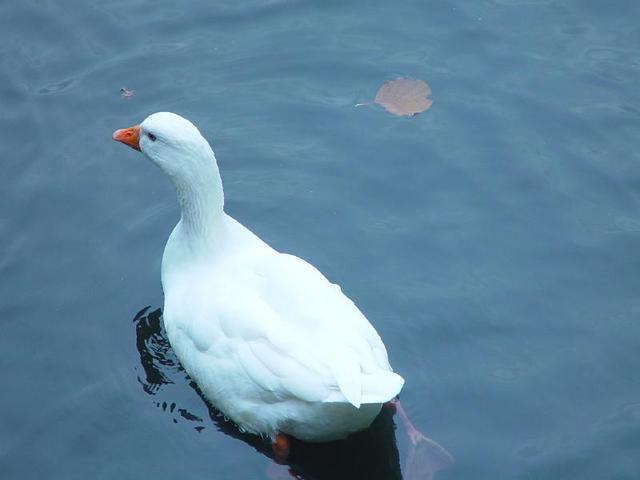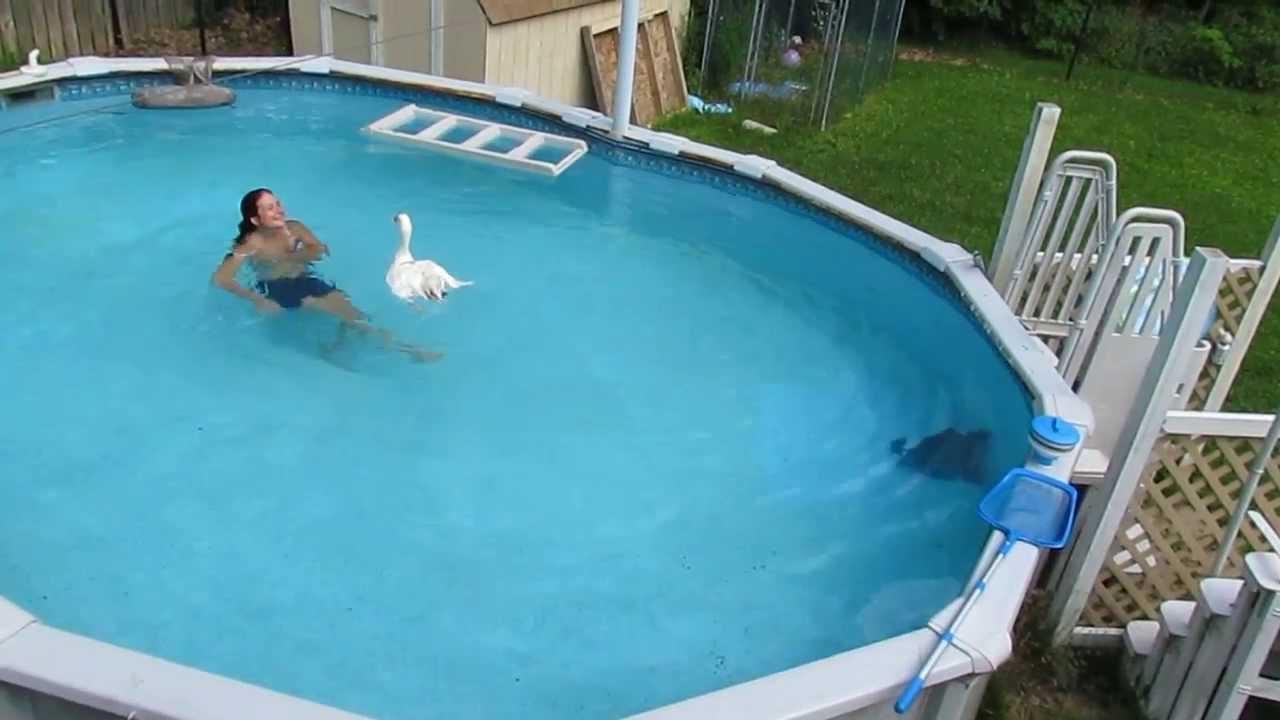The first image is the image on the left, the second image is the image on the right. For the images displayed, is the sentence "There are more than three ducks in water." factually correct? Answer yes or no. No. 